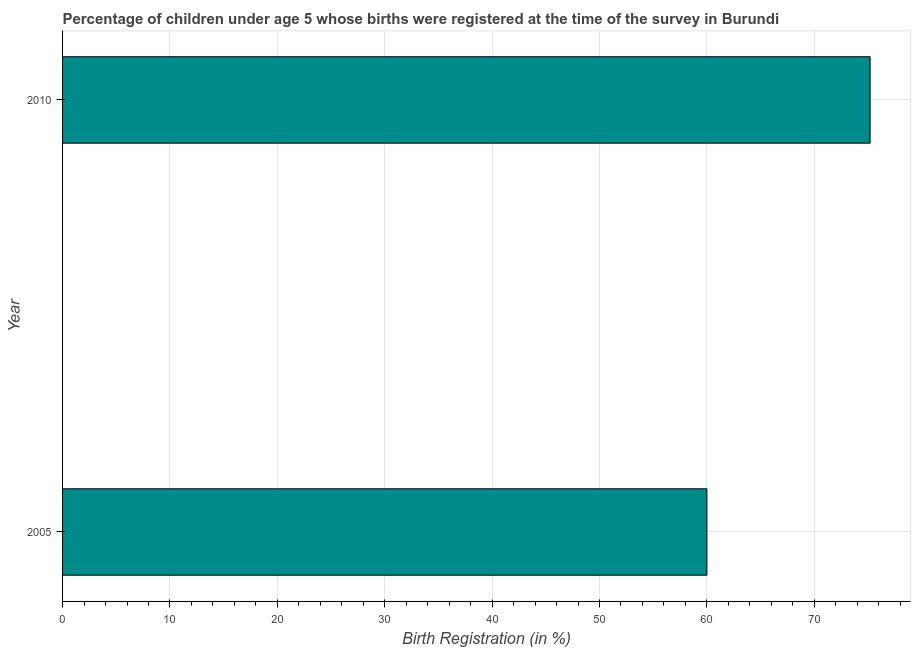What is the title of the graph?
Your response must be concise. Percentage of children under age 5 whose births were registered at the time of the survey in Burundi. What is the label or title of the X-axis?
Make the answer very short. Birth Registration (in %). What is the label or title of the Y-axis?
Provide a succinct answer. Year. What is the birth registration in 2010?
Give a very brief answer. 75.2. Across all years, what is the maximum birth registration?
Offer a terse response. 75.2. Across all years, what is the minimum birth registration?
Ensure brevity in your answer.  60. What is the sum of the birth registration?
Ensure brevity in your answer.  135.2. What is the difference between the birth registration in 2005 and 2010?
Keep it short and to the point. -15.2. What is the average birth registration per year?
Keep it short and to the point. 67.6. What is the median birth registration?
Your answer should be compact. 67.6. What is the ratio of the birth registration in 2005 to that in 2010?
Make the answer very short. 0.8. How many bars are there?
Give a very brief answer. 2. Are all the bars in the graph horizontal?
Your response must be concise. Yes. How many years are there in the graph?
Provide a short and direct response. 2. Are the values on the major ticks of X-axis written in scientific E-notation?
Your response must be concise. No. What is the Birth Registration (in %) in 2010?
Give a very brief answer. 75.2. What is the difference between the Birth Registration (in %) in 2005 and 2010?
Your answer should be very brief. -15.2. What is the ratio of the Birth Registration (in %) in 2005 to that in 2010?
Keep it short and to the point. 0.8. 